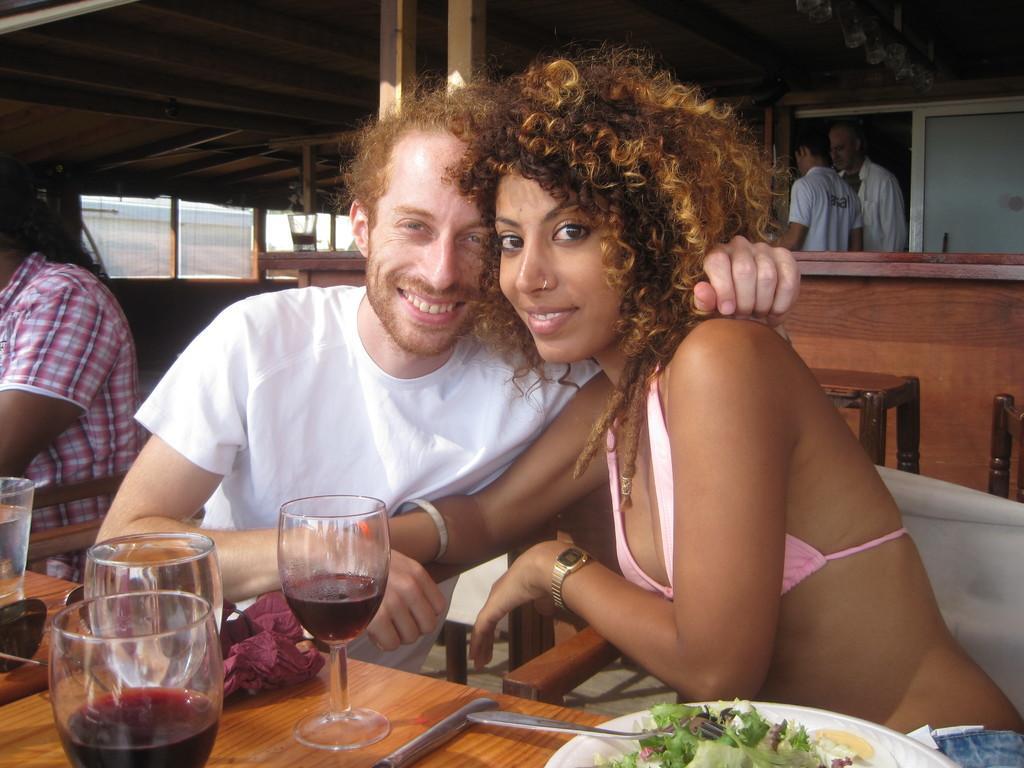Could you give a brief overview of what you see in this image? In this image we can see few people sitting on the chair. There are few drink glasses on the table. There is some food on the plate. There are few spoons on the table. There are few people standing at the right side of the image. There is a glass on the table at the left side of the image. There are few chairs at the right side of the image. 